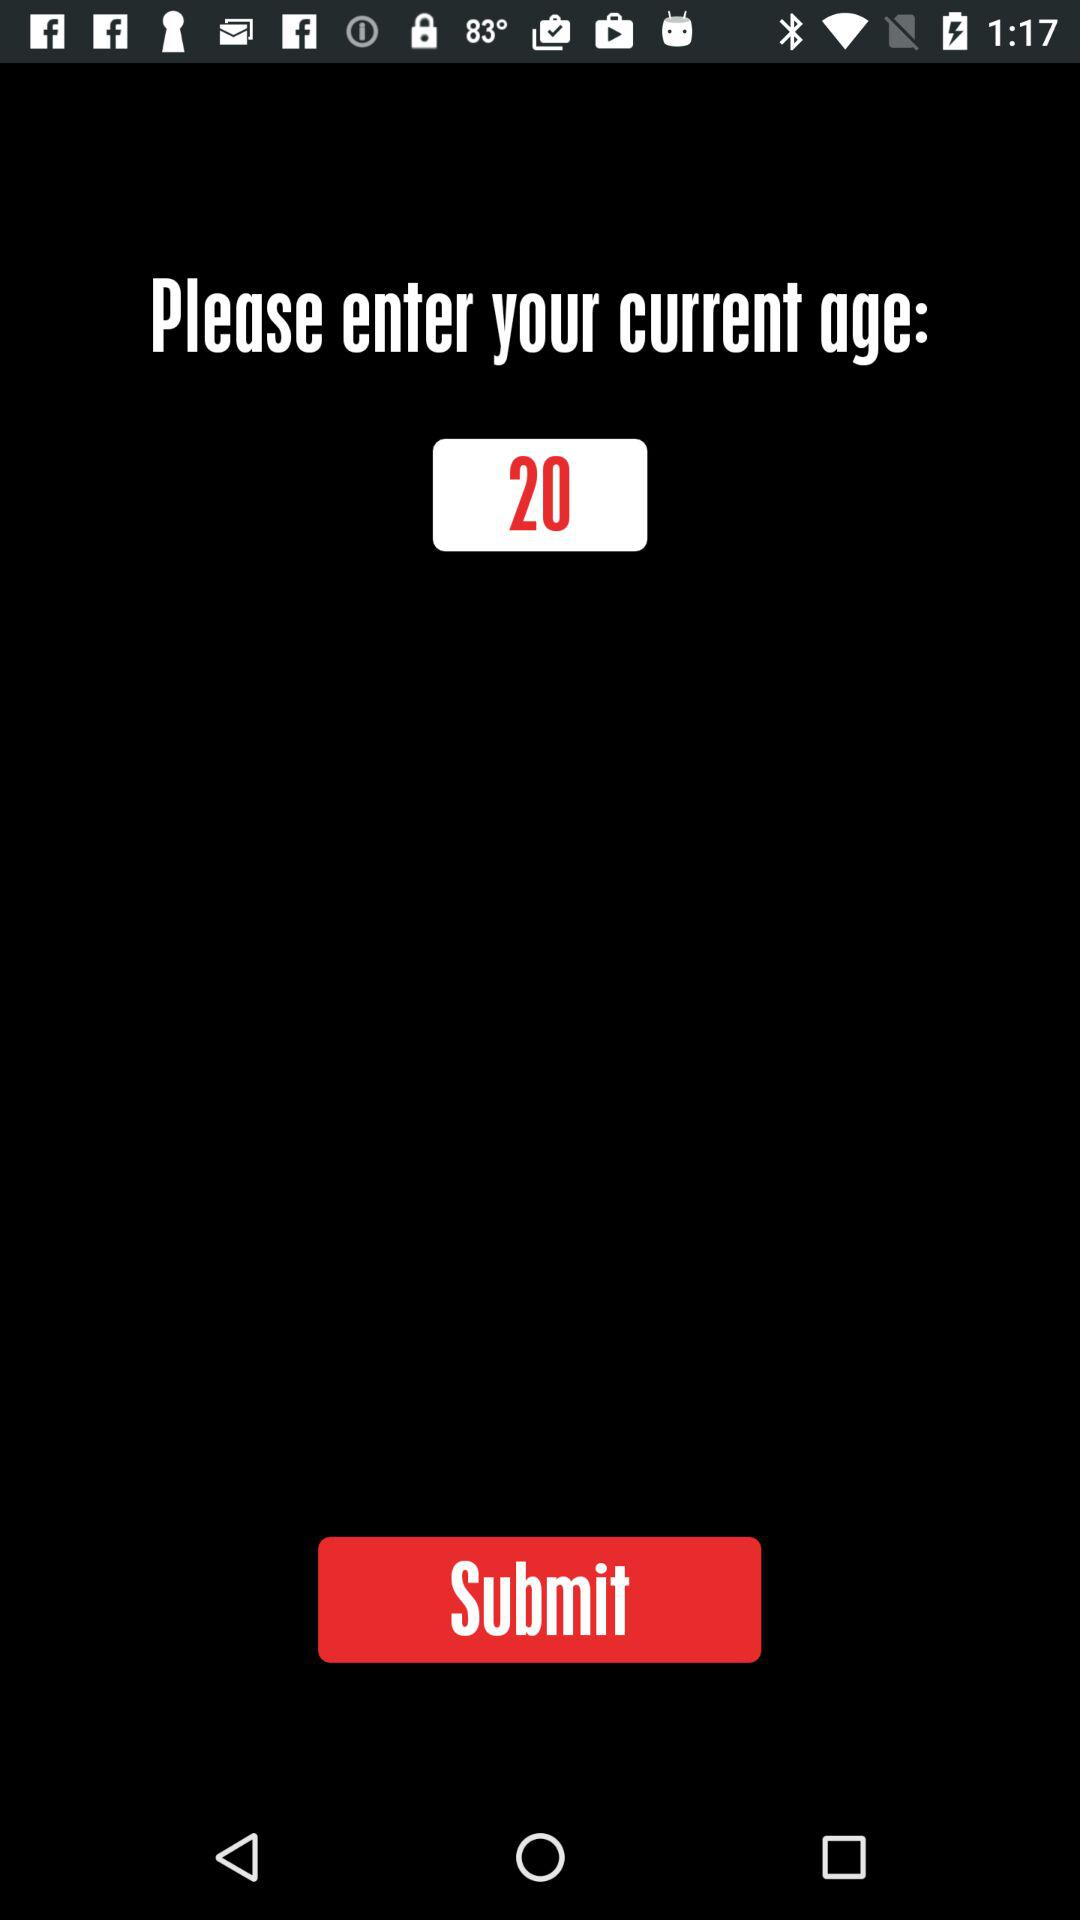What is the entered age? The entered age is 20. 